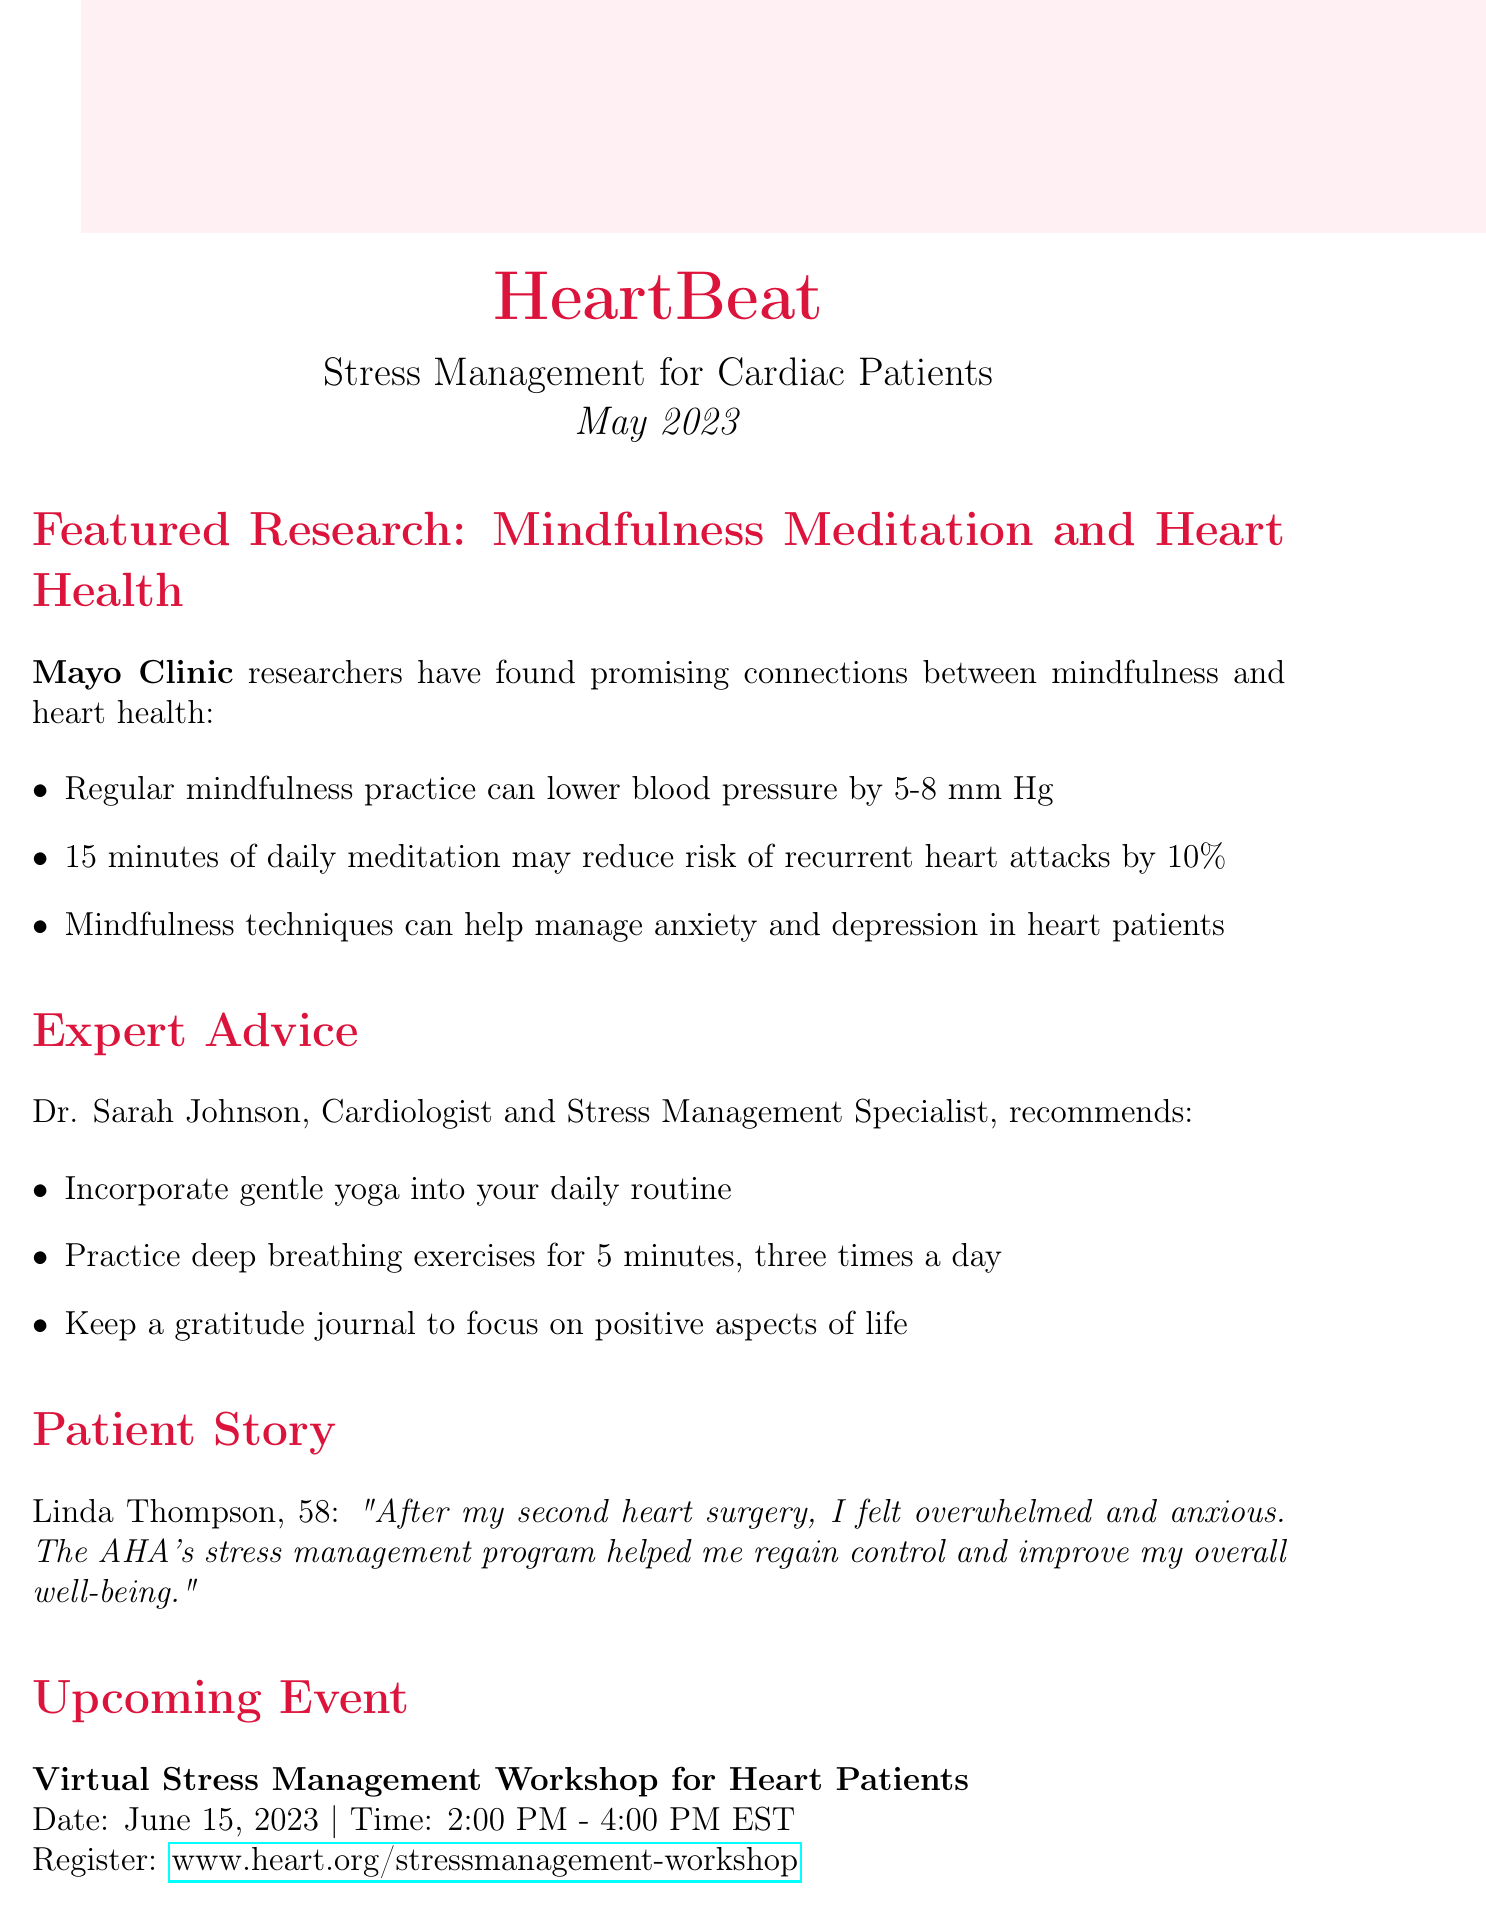What is the title of the newsletter? The title of the newsletter is clearly stated at the beginning of the document.
Answer: HeartBeat: Stress Management for Cardiac Patients When was the issue date of the newsletter? The issue date is mentioned prominently, indicating when the newsletter was released.
Answer: May 2023 Who conducted the featured research on mindfulness meditation? The document attributes the research to a specific institution, which is a key part of the information.
Answer: Mayo Clinic What can regular mindfulness practice lower blood pressure by? This detail is provided in the key findings, which enumerate specific impacts of mindfulness practice.
Answer: 5-8 mm Hg What is one tip provided by Dr. Sarah Johnson? The document lists several tips, but this question can be answered with any single tip from the expert advice section.
Answer: Incorporate gentle yoga into your daily routine How long is the upcoming virtual workshop scheduled for? The time duration for the event is specified in the section detailing the upcoming events.
Answer: 2 hours What is the purpose of the HeartCalm app? The description of the app outlines its offerings, which can answer this question.
Answer: Guided meditations and breathing exercises Who is featured in the patient story? The document includes a personal account, mentioning the individual by name as part of a narrative.
Answer: Linda Thompson What is the registration link for the upcoming workshop? The link to register for the event is provided, making it easy to find.
Answer: www.heart.org/stressmanagement-workshop 